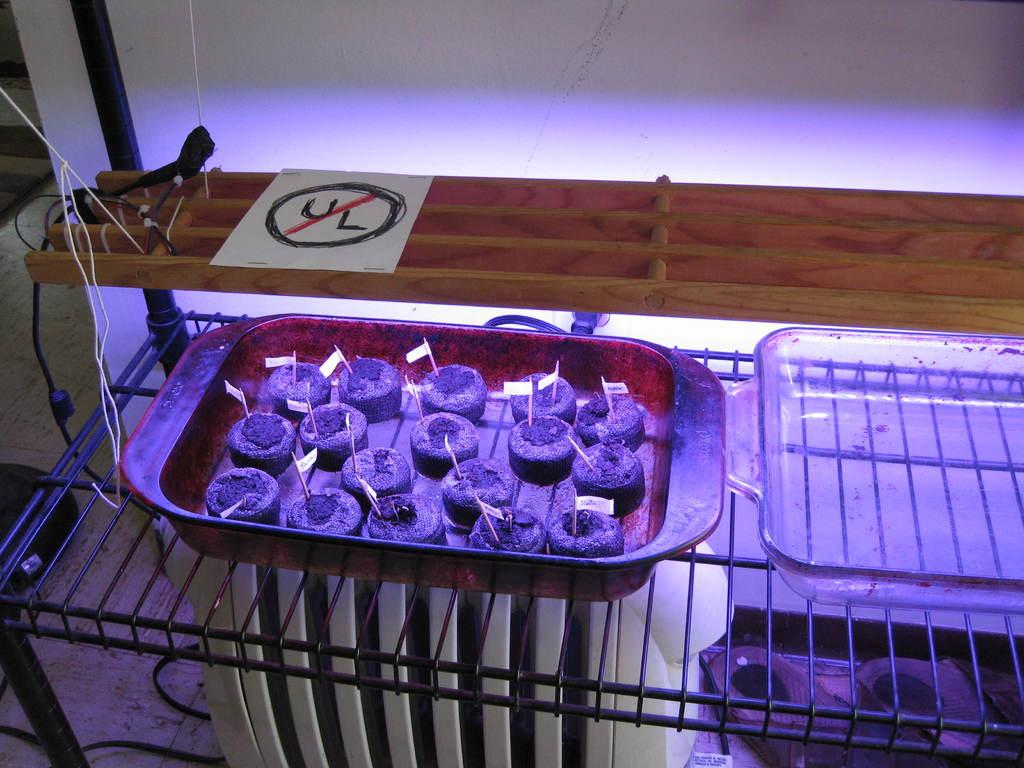<image>
Describe the image concisely. A non UL approved lighting fixture above some plant seedlings. 